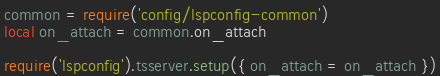<code> <loc_0><loc_0><loc_500><loc_500><_Lua_>common = require('config/lspconfig-common')
local on_attach = common.on_attach

require('lspconfig').tsserver.setup({ on_attach = on_attach })
</code> 